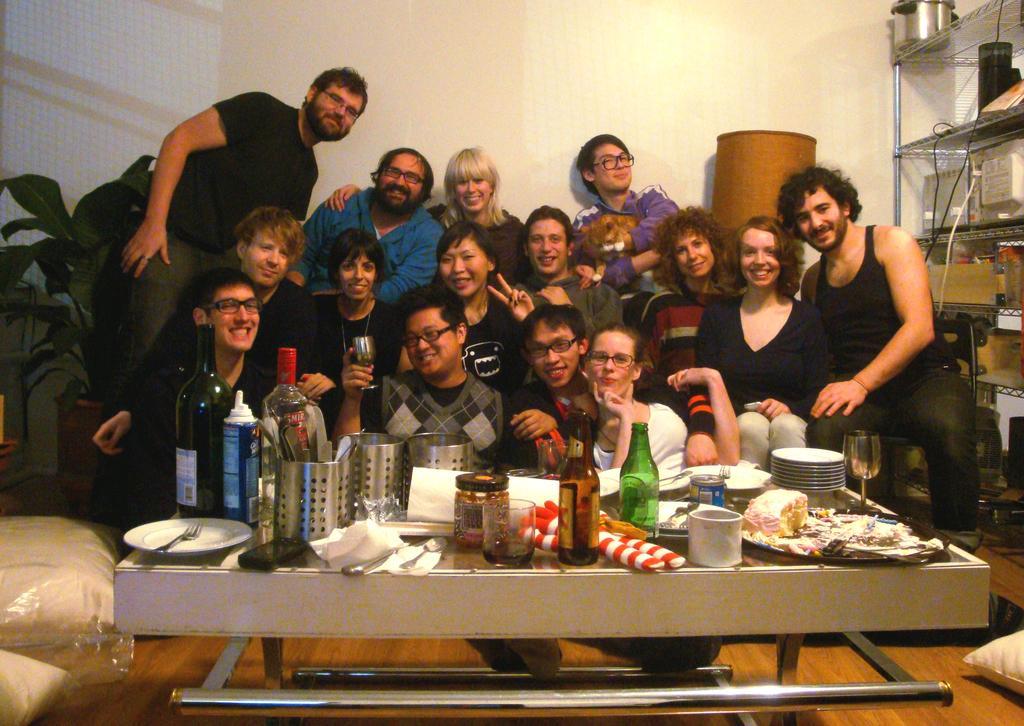Describe this image in one or two sentences. In the foreground of this image, on the table, there are few bottles, a tin, cup, platters, forks and few containers on it. In the background, there are a group of people posing to the camera. On the right, there are few objects in the rack. On the left, there is a plant. At the top, there is a wall and we can also see pillows on the floor. 